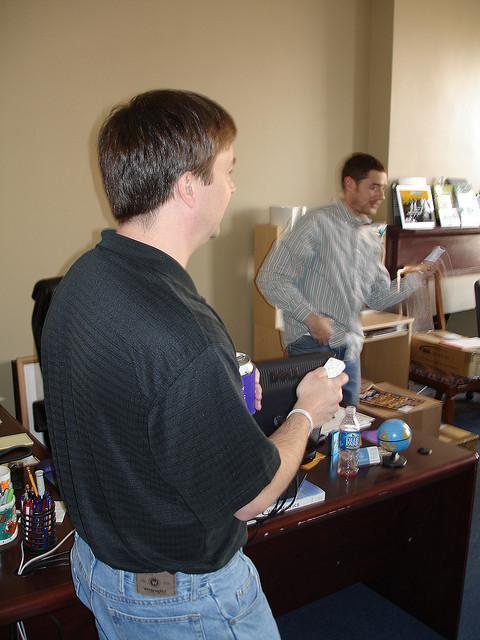What is the blue round object sitting on the desk a model of?
Choose the right answer from the provided options to respond to the question.
Options: Planet, gyroscope, moon, globe. Globe. 